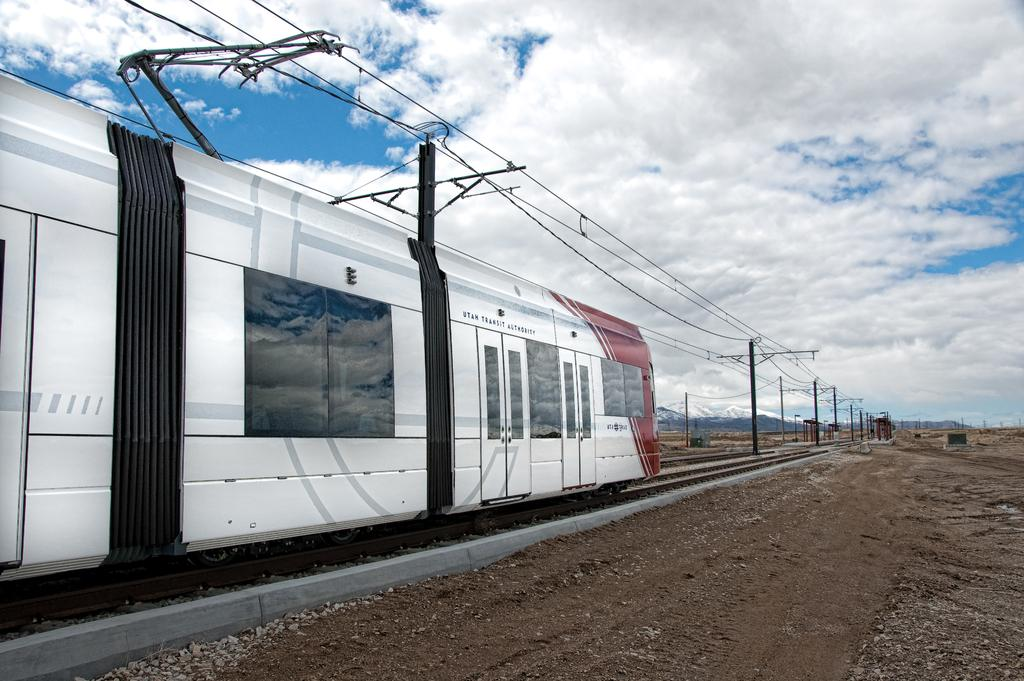What is the main subject of the image? The main subject of the image is a train. What is the train doing in the image? The train is moving on a railway track. What can be seen in the image besides the train? There are poles, wires, the ground, mountains, and the sky visible in the image. What is the condition of the sky in the image? The sky is visible in the background of the image, and clouds are present. What theory is being proposed by the train in the image? There is no theory being proposed by the train in the image; it is simply moving on a railway track. What type of fiction is depicted in the image? There is no fiction depicted in the image; it is a realistic scene of a train moving on a railway track. 